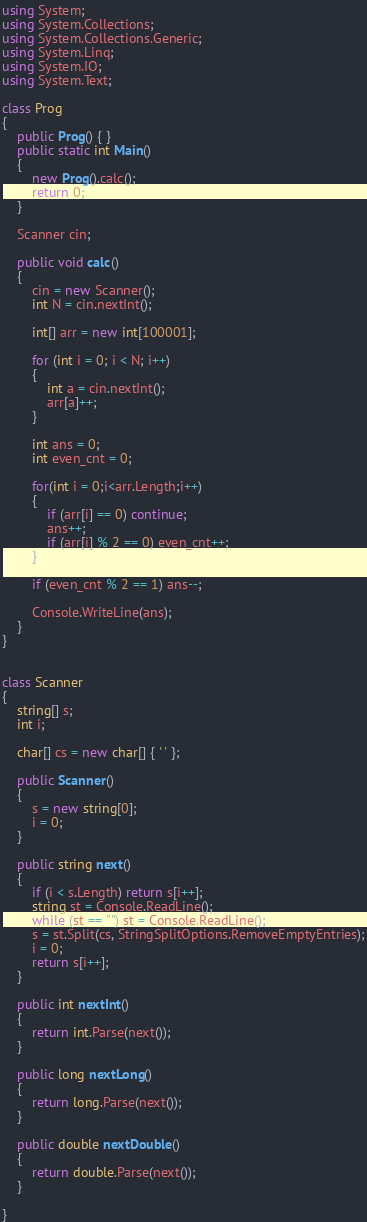Convert code to text. <code><loc_0><loc_0><loc_500><loc_500><_C#_>using System;
using System.Collections;
using System.Collections.Generic;
using System.Linq;
using System.IO;
using System.Text;

class Prog
{
    public Prog() { }
    public static int Main()
    {
        new Prog().calc();
        return 0;
    }

    Scanner cin;

    public void calc()
    {
        cin = new Scanner();
        int N = cin.nextInt();

        int[] arr = new int[100001];

        for (int i = 0; i < N; i++)
        {
            int a = cin.nextInt();
            arr[a]++;
        }

        int ans = 0;
        int even_cnt = 0;
       
        for(int i = 0;i<arr.Length;i++)
        {
            if (arr[i] == 0) continue;
            ans++;
            if (arr[i] % 2 == 0) even_cnt++;
        }

        if (even_cnt % 2 == 1) ans--;
        
        Console.WriteLine(ans);
    }
}


class Scanner
{
    string[] s;
    int i;

    char[] cs = new char[] { ' ' };

    public Scanner()
    {
        s = new string[0];
        i = 0;
    }

    public string next()
    {
        if (i < s.Length) return s[i++];
        string st = Console.ReadLine();
        while (st == "") st = Console.ReadLine();
        s = st.Split(cs, StringSplitOptions.RemoveEmptyEntries);
        i = 0;
        return s[i++];
    }

    public int nextInt()
    {
        return int.Parse(next());
    }

    public long nextLong()
    {
        return long.Parse(next());
    }

    public double nextDouble()
    {
        return double.Parse(next());
    }

}
</code> 